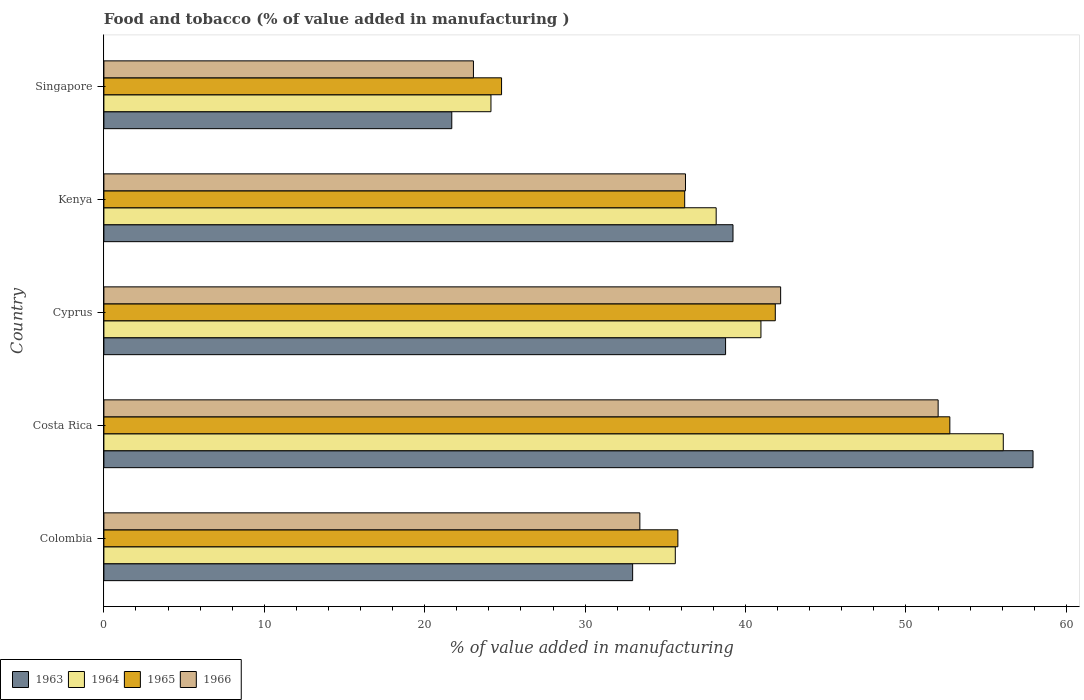How many different coloured bars are there?
Ensure brevity in your answer.  4. How many groups of bars are there?
Your answer should be compact. 5. Are the number of bars on each tick of the Y-axis equal?
Offer a very short reply. Yes. What is the label of the 4th group of bars from the top?
Keep it short and to the point. Costa Rica. In how many cases, is the number of bars for a given country not equal to the number of legend labels?
Offer a very short reply. 0. What is the value added in manufacturing food and tobacco in 1966 in Singapore?
Your answer should be very brief. 23.04. Across all countries, what is the maximum value added in manufacturing food and tobacco in 1964?
Give a very brief answer. 56.07. Across all countries, what is the minimum value added in manufacturing food and tobacco in 1964?
Ensure brevity in your answer.  24.13. In which country was the value added in manufacturing food and tobacco in 1964 minimum?
Your answer should be compact. Singapore. What is the total value added in manufacturing food and tobacco in 1964 in the graph?
Offer a terse response. 194.94. What is the difference between the value added in manufacturing food and tobacco in 1963 in Colombia and that in Costa Rica?
Your answer should be compact. -24.96. What is the difference between the value added in manufacturing food and tobacco in 1965 in Colombia and the value added in manufacturing food and tobacco in 1966 in Cyprus?
Keep it short and to the point. -6.41. What is the average value added in manufacturing food and tobacco in 1966 per country?
Make the answer very short. 37.38. What is the difference between the value added in manufacturing food and tobacco in 1965 and value added in manufacturing food and tobacco in 1963 in Kenya?
Offer a very short reply. -3.01. In how many countries, is the value added in manufacturing food and tobacco in 1964 greater than 6 %?
Your answer should be compact. 5. What is the ratio of the value added in manufacturing food and tobacco in 1966 in Kenya to that in Singapore?
Provide a succinct answer. 1.57. What is the difference between the highest and the second highest value added in manufacturing food and tobacco in 1963?
Keep it short and to the point. 18.7. What is the difference between the highest and the lowest value added in manufacturing food and tobacco in 1964?
Keep it short and to the point. 31.94. In how many countries, is the value added in manufacturing food and tobacco in 1964 greater than the average value added in manufacturing food and tobacco in 1964 taken over all countries?
Your response must be concise. 2. What does the 1st bar from the top in Cyprus represents?
Provide a short and direct response. 1966. What does the 4th bar from the bottom in Costa Rica represents?
Your answer should be very brief. 1966. Is it the case that in every country, the sum of the value added in manufacturing food and tobacco in 1966 and value added in manufacturing food and tobacco in 1963 is greater than the value added in manufacturing food and tobacco in 1964?
Ensure brevity in your answer.  Yes. How many bars are there?
Provide a succinct answer. 20. Are all the bars in the graph horizontal?
Your answer should be compact. Yes. How many countries are there in the graph?
Ensure brevity in your answer.  5. What is the difference between two consecutive major ticks on the X-axis?
Provide a short and direct response. 10. Are the values on the major ticks of X-axis written in scientific E-notation?
Your response must be concise. No. Does the graph contain any zero values?
Provide a short and direct response. No. Where does the legend appear in the graph?
Provide a succinct answer. Bottom left. How are the legend labels stacked?
Provide a short and direct response. Horizontal. What is the title of the graph?
Ensure brevity in your answer.  Food and tobacco (% of value added in manufacturing ). Does "2013" appear as one of the legend labels in the graph?
Give a very brief answer. No. What is the label or title of the X-axis?
Offer a terse response. % of value added in manufacturing. What is the % of value added in manufacturing in 1963 in Colombia?
Keep it short and to the point. 32.96. What is the % of value added in manufacturing in 1964 in Colombia?
Make the answer very short. 35.62. What is the % of value added in manufacturing in 1965 in Colombia?
Ensure brevity in your answer.  35.78. What is the % of value added in manufacturing in 1966 in Colombia?
Your answer should be very brief. 33.41. What is the % of value added in manufacturing of 1963 in Costa Rica?
Give a very brief answer. 57.92. What is the % of value added in manufacturing in 1964 in Costa Rica?
Make the answer very short. 56.07. What is the % of value added in manufacturing in 1965 in Costa Rica?
Give a very brief answer. 52.73. What is the % of value added in manufacturing in 1966 in Costa Rica?
Offer a terse response. 52. What is the % of value added in manufacturing in 1963 in Cyprus?
Your answer should be very brief. 38.75. What is the % of value added in manufacturing of 1964 in Cyprus?
Offer a very short reply. 40.96. What is the % of value added in manufacturing of 1965 in Cyprus?
Offer a terse response. 41.85. What is the % of value added in manufacturing of 1966 in Cyprus?
Ensure brevity in your answer.  42.19. What is the % of value added in manufacturing of 1963 in Kenya?
Keep it short and to the point. 39.22. What is the % of value added in manufacturing in 1964 in Kenya?
Keep it short and to the point. 38.17. What is the % of value added in manufacturing of 1965 in Kenya?
Offer a terse response. 36.2. What is the % of value added in manufacturing in 1966 in Kenya?
Your answer should be very brief. 36.25. What is the % of value added in manufacturing in 1963 in Singapore?
Make the answer very short. 21.69. What is the % of value added in manufacturing in 1964 in Singapore?
Make the answer very short. 24.13. What is the % of value added in manufacturing in 1965 in Singapore?
Provide a short and direct response. 24.79. What is the % of value added in manufacturing of 1966 in Singapore?
Offer a terse response. 23.04. Across all countries, what is the maximum % of value added in manufacturing in 1963?
Your response must be concise. 57.92. Across all countries, what is the maximum % of value added in manufacturing of 1964?
Your response must be concise. 56.07. Across all countries, what is the maximum % of value added in manufacturing of 1965?
Ensure brevity in your answer.  52.73. Across all countries, what is the maximum % of value added in manufacturing in 1966?
Offer a terse response. 52. Across all countries, what is the minimum % of value added in manufacturing of 1963?
Make the answer very short. 21.69. Across all countries, what is the minimum % of value added in manufacturing of 1964?
Give a very brief answer. 24.13. Across all countries, what is the minimum % of value added in manufacturing of 1965?
Your answer should be very brief. 24.79. Across all countries, what is the minimum % of value added in manufacturing in 1966?
Offer a very short reply. 23.04. What is the total % of value added in manufacturing in 1963 in the graph?
Offer a very short reply. 190.54. What is the total % of value added in manufacturing in 1964 in the graph?
Provide a short and direct response. 194.94. What is the total % of value added in manufacturing of 1965 in the graph?
Provide a succinct answer. 191.36. What is the total % of value added in manufacturing of 1966 in the graph?
Provide a short and direct response. 186.89. What is the difference between the % of value added in manufacturing in 1963 in Colombia and that in Costa Rica?
Make the answer very short. -24.96. What is the difference between the % of value added in manufacturing in 1964 in Colombia and that in Costa Rica?
Offer a very short reply. -20.45. What is the difference between the % of value added in manufacturing in 1965 in Colombia and that in Costa Rica?
Your answer should be compact. -16.95. What is the difference between the % of value added in manufacturing in 1966 in Colombia and that in Costa Rica?
Offer a very short reply. -18.59. What is the difference between the % of value added in manufacturing in 1963 in Colombia and that in Cyprus?
Ensure brevity in your answer.  -5.79. What is the difference between the % of value added in manufacturing in 1964 in Colombia and that in Cyprus?
Your answer should be compact. -5.34. What is the difference between the % of value added in manufacturing of 1965 in Colombia and that in Cyprus?
Give a very brief answer. -6.07. What is the difference between the % of value added in manufacturing in 1966 in Colombia and that in Cyprus?
Your answer should be very brief. -8.78. What is the difference between the % of value added in manufacturing in 1963 in Colombia and that in Kenya?
Your response must be concise. -6.26. What is the difference between the % of value added in manufacturing in 1964 in Colombia and that in Kenya?
Your answer should be very brief. -2.55. What is the difference between the % of value added in manufacturing of 1965 in Colombia and that in Kenya?
Provide a succinct answer. -0.42. What is the difference between the % of value added in manufacturing in 1966 in Colombia and that in Kenya?
Provide a short and direct response. -2.84. What is the difference between the % of value added in manufacturing in 1963 in Colombia and that in Singapore?
Ensure brevity in your answer.  11.27. What is the difference between the % of value added in manufacturing of 1964 in Colombia and that in Singapore?
Your response must be concise. 11.49. What is the difference between the % of value added in manufacturing in 1965 in Colombia and that in Singapore?
Offer a terse response. 10.99. What is the difference between the % of value added in manufacturing in 1966 in Colombia and that in Singapore?
Offer a terse response. 10.37. What is the difference between the % of value added in manufacturing in 1963 in Costa Rica and that in Cyprus?
Offer a very short reply. 19.17. What is the difference between the % of value added in manufacturing of 1964 in Costa Rica and that in Cyprus?
Your answer should be compact. 15.11. What is the difference between the % of value added in manufacturing of 1965 in Costa Rica and that in Cyprus?
Make the answer very short. 10.88. What is the difference between the % of value added in manufacturing in 1966 in Costa Rica and that in Cyprus?
Keep it short and to the point. 9.82. What is the difference between the % of value added in manufacturing of 1963 in Costa Rica and that in Kenya?
Offer a very short reply. 18.7. What is the difference between the % of value added in manufacturing of 1964 in Costa Rica and that in Kenya?
Ensure brevity in your answer.  17.9. What is the difference between the % of value added in manufacturing in 1965 in Costa Rica and that in Kenya?
Provide a succinct answer. 16.53. What is the difference between the % of value added in manufacturing in 1966 in Costa Rica and that in Kenya?
Give a very brief answer. 15.75. What is the difference between the % of value added in manufacturing of 1963 in Costa Rica and that in Singapore?
Your response must be concise. 36.23. What is the difference between the % of value added in manufacturing in 1964 in Costa Rica and that in Singapore?
Make the answer very short. 31.94. What is the difference between the % of value added in manufacturing of 1965 in Costa Rica and that in Singapore?
Keep it short and to the point. 27.94. What is the difference between the % of value added in manufacturing of 1966 in Costa Rica and that in Singapore?
Your answer should be very brief. 28.97. What is the difference between the % of value added in manufacturing in 1963 in Cyprus and that in Kenya?
Your answer should be compact. -0.46. What is the difference between the % of value added in manufacturing in 1964 in Cyprus and that in Kenya?
Make the answer very short. 2.79. What is the difference between the % of value added in manufacturing of 1965 in Cyprus and that in Kenya?
Ensure brevity in your answer.  5.65. What is the difference between the % of value added in manufacturing in 1966 in Cyprus and that in Kenya?
Keep it short and to the point. 5.93. What is the difference between the % of value added in manufacturing of 1963 in Cyprus and that in Singapore?
Give a very brief answer. 17.07. What is the difference between the % of value added in manufacturing in 1964 in Cyprus and that in Singapore?
Your response must be concise. 16.83. What is the difference between the % of value added in manufacturing of 1965 in Cyprus and that in Singapore?
Your answer should be very brief. 17.06. What is the difference between the % of value added in manufacturing of 1966 in Cyprus and that in Singapore?
Your response must be concise. 19.15. What is the difference between the % of value added in manufacturing in 1963 in Kenya and that in Singapore?
Give a very brief answer. 17.53. What is the difference between the % of value added in manufacturing of 1964 in Kenya and that in Singapore?
Give a very brief answer. 14.04. What is the difference between the % of value added in manufacturing of 1965 in Kenya and that in Singapore?
Offer a terse response. 11.41. What is the difference between the % of value added in manufacturing in 1966 in Kenya and that in Singapore?
Your answer should be compact. 13.22. What is the difference between the % of value added in manufacturing in 1963 in Colombia and the % of value added in manufacturing in 1964 in Costa Rica?
Your answer should be very brief. -23.11. What is the difference between the % of value added in manufacturing in 1963 in Colombia and the % of value added in manufacturing in 1965 in Costa Rica?
Your response must be concise. -19.77. What is the difference between the % of value added in manufacturing in 1963 in Colombia and the % of value added in manufacturing in 1966 in Costa Rica?
Ensure brevity in your answer.  -19.04. What is the difference between the % of value added in manufacturing in 1964 in Colombia and the % of value added in manufacturing in 1965 in Costa Rica?
Your answer should be compact. -17.11. What is the difference between the % of value added in manufacturing in 1964 in Colombia and the % of value added in manufacturing in 1966 in Costa Rica?
Provide a short and direct response. -16.38. What is the difference between the % of value added in manufacturing in 1965 in Colombia and the % of value added in manufacturing in 1966 in Costa Rica?
Your answer should be very brief. -16.22. What is the difference between the % of value added in manufacturing of 1963 in Colombia and the % of value added in manufacturing of 1964 in Cyprus?
Your answer should be compact. -8. What is the difference between the % of value added in manufacturing in 1963 in Colombia and the % of value added in manufacturing in 1965 in Cyprus?
Offer a very short reply. -8.89. What is the difference between the % of value added in manufacturing in 1963 in Colombia and the % of value added in manufacturing in 1966 in Cyprus?
Make the answer very short. -9.23. What is the difference between the % of value added in manufacturing of 1964 in Colombia and the % of value added in manufacturing of 1965 in Cyprus?
Ensure brevity in your answer.  -6.23. What is the difference between the % of value added in manufacturing in 1964 in Colombia and the % of value added in manufacturing in 1966 in Cyprus?
Provide a succinct answer. -6.57. What is the difference between the % of value added in manufacturing in 1965 in Colombia and the % of value added in manufacturing in 1966 in Cyprus?
Provide a succinct answer. -6.41. What is the difference between the % of value added in manufacturing of 1963 in Colombia and the % of value added in manufacturing of 1964 in Kenya?
Offer a very short reply. -5.21. What is the difference between the % of value added in manufacturing of 1963 in Colombia and the % of value added in manufacturing of 1965 in Kenya?
Give a very brief answer. -3.24. What is the difference between the % of value added in manufacturing of 1963 in Colombia and the % of value added in manufacturing of 1966 in Kenya?
Your answer should be very brief. -3.29. What is the difference between the % of value added in manufacturing of 1964 in Colombia and the % of value added in manufacturing of 1965 in Kenya?
Give a very brief answer. -0.58. What is the difference between the % of value added in manufacturing of 1964 in Colombia and the % of value added in manufacturing of 1966 in Kenya?
Offer a terse response. -0.63. What is the difference between the % of value added in manufacturing in 1965 in Colombia and the % of value added in manufacturing in 1966 in Kenya?
Provide a succinct answer. -0.47. What is the difference between the % of value added in manufacturing of 1963 in Colombia and the % of value added in manufacturing of 1964 in Singapore?
Keep it short and to the point. 8.83. What is the difference between the % of value added in manufacturing of 1963 in Colombia and the % of value added in manufacturing of 1965 in Singapore?
Give a very brief answer. 8.17. What is the difference between the % of value added in manufacturing in 1963 in Colombia and the % of value added in manufacturing in 1966 in Singapore?
Give a very brief answer. 9.92. What is the difference between the % of value added in manufacturing in 1964 in Colombia and the % of value added in manufacturing in 1965 in Singapore?
Your answer should be very brief. 10.83. What is the difference between the % of value added in manufacturing of 1964 in Colombia and the % of value added in manufacturing of 1966 in Singapore?
Make the answer very short. 12.58. What is the difference between the % of value added in manufacturing of 1965 in Colombia and the % of value added in manufacturing of 1966 in Singapore?
Provide a short and direct response. 12.74. What is the difference between the % of value added in manufacturing of 1963 in Costa Rica and the % of value added in manufacturing of 1964 in Cyprus?
Provide a short and direct response. 16.96. What is the difference between the % of value added in manufacturing of 1963 in Costa Rica and the % of value added in manufacturing of 1965 in Cyprus?
Provide a succinct answer. 16.07. What is the difference between the % of value added in manufacturing of 1963 in Costa Rica and the % of value added in manufacturing of 1966 in Cyprus?
Offer a very short reply. 15.73. What is the difference between the % of value added in manufacturing in 1964 in Costa Rica and the % of value added in manufacturing in 1965 in Cyprus?
Offer a terse response. 14.21. What is the difference between the % of value added in manufacturing in 1964 in Costa Rica and the % of value added in manufacturing in 1966 in Cyprus?
Offer a terse response. 13.88. What is the difference between the % of value added in manufacturing in 1965 in Costa Rica and the % of value added in manufacturing in 1966 in Cyprus?
Make the answer very short. 10.55. What is the difference between the % of value added in manufacturing in 1963 in Costa Rica and the % of value added in manufacturing in 1964 in Kenya?
Offer a terse response. 19.75. What is the difference between the % of value added in manufacturing in 1963 in Costa Rica and the % of value added in manufacturing in 1965 in Kenya?
Provide a short and direct response. 21.72. What is the difference between the % of value added in manufacturing in 1963 in Costa Rica and the % of value added in manufacturing in 1966 in Kenya?
Provide a succinct answer. 21.67. What is the difference between the % of value added in manufacturing of 1964 in Costa Rica and the % of value added in manufacturing of 1965 in Kenya?
Give a very brief answer. 19.86. What is the difference between the % of value added in manufacturing of 1964 in Costa Rica and the % of value added in manufacturing of 1966 in Kenya?
Give a very brief answer. 19.81. What is the difference between the % of value added in manufacturing in 1965 in Costa Rica and the % of value added in manufacturing in 1966 in Kenya?
Offer a terse response. 16.48. What is the difference between the % of value added in manufacturing in 1963 in Costa Rica and the % of value added in manufacturing in 1964 in Singapore?
Offer a very short reply. 33.79. What is the difference between the % of value added in manufacturing of 1963 in Costa Rica and the % of value added in manufacturing of 1965 in Singapore?
Your response must be concise. 33.13. What is the difference between the % of value added in manufacturing of 1963 in Costa Rica and the % of value added in manufacturing of 1966 in Singapore?
Make the answer very short. 34.88. What is the difference between the % of value added in manufacturing of 1964 in Costa Rica and the % of value added in manufacturing of 1965 in Singapore?
Keep it short and to the point. 31.28. What is the difference between the % of value added in manufacturing of 1964 in Costa Rica and the % of value added in manufacturing of 1966 in Singapore?
Your response must be concise. 33.03. What is the difference between the % of value added in manufacturing in 1965 in Costa Rica and the % of value added in manufacturing in 1966 in Singapore?
Your answer should be very brief. 29.7. What is the difference between the % of value added in manufacturing of 1963 in Cyprus and the % of value added in manufacturing of 1964 in Kenya?
Keep it short and to the point. 0.59. What is the difference between the % of value added in manufacturing in 1963 in Cyprus and the % of value added in manufacturing in 1965 in Kenya?
Your response must be concise. 2.55. What is the difference between the % of value added in manufacturing of 1963 in Cyprus and the % of value added in manufacturing of 1966 in Kenya?
Provide a short and direct response. 2.5. What is the difference between the % of value added in manufacturing of 1964 in Cyprus and the % of value added in manufacturing of 1965 in Kenya?
Ensure brevity in your answer.  4.75. What is the difference between the % of value added in manufacturing in 1964 in Cyprus and the % of value added in manufacturing in 1966 in Kenya?
Keep it short and to the point. 4.7. What is the difference between the % of value added in manufacturing of 1965 in Cyprus and the % of value added in manufacturing of 1966 in Kenya?
Your response must be concise. 5.6. What is the difference between the % of value added in manufacturing in 1963 in Cyprus and the % of value added in manufacturing in 1964 in Singapore?
Provide a short and direct response. 14.63. What is the difference between the % of value added in manufacturing of 1963 in Cyprus and the % of value added in manufacturing of 1965 in Singapore?
Your answer should be very brief. 13.96. What is the difference between the % of value added in manufacturing in 1963 in Cyprus and the % of value added in manufacturing in 1966 in Singapore?
Provide a succinct answer. 15.72. What is the difference between the % of value added in manufacturing of 1964 in Cyprus and the % of value added in manufacturing of 1965 in Singapore?
Give a very brief answer. 16.17. What is the difference between the % of value added in manufacturing in 1964 in Cyprus and the % of value added in manufacturing in 1966 in Singapore?
Keep it short and to the point. 17.92. What is the difference between the % of value added in manufacturing in 1965 in Cyprus and the % of value added in manufacturing in 1966 in Singapore?
Offer a very short reply. 18.82. What is the difference between the % of value added in manufacturing of 1963 in Kenya and the % of value added in manufacturing of 1964 in Singapore?
Provide a short and direct response. 15.09. What is the difference between the % of value added in manufacturing in 1963 in Kenya and the % of value added in manufacturing in 1965 in Singapore?
Ensure brevity in your answer.  14.43. What is the difference between the % of value added in manufacturing in 1963 in Kenya and the % of value added in manufacturing in 1966 in Singapore?
Provide a succinct answer. 16.18. What is the difference between the % of value added in manufacturing of 1964 in Kenya and the % of value added in manufacturing of 1965 in Singapore?
Provide a succinct answer. 13.38. What is the difference between the % of value added in manufacturing in 1964 in Kenya and the % of value added in manufacturing in 1966 in Singapore?
Your response must be concise. 15.13. What is the difference between the % of value added in manufacturing of 1965 in Kenya and the % of value added in manufacturing of 1966 in Singapore?
Your response must be concise. 13.17. What is the average % of value added in manufacturing of 1963 per country?
Ensure brevity in your answer.  38.11. What is the average % of value added in manufacturing of 1964 per country?
Keep it short and to the point. 38.99. What is the average % of value added in manufacturing in 1965 per country?
Provide a succinct answer. 38.27. What is the average % of value added in manufacturing in 1966 per country?
Your response must be concise. 37.38. What is the difference between the % of value added in manufacturing in 1963 and % of value added in manufacturing in 1964 in Colombia?
Make the answer very short. -2.66. What is the difference between the % of value added in manufacturing of 1963 and % of value added in manufacturing of 1965 in Colombia?
Give a very brief answer. -2.82. What is the difference between the % of value added in manufacturing of 1963 and % of value added in manufacturing of 1966 in Colombia?
Offer a very short reply. -0.45. What is the difference between the % of value added in manufacturing in 1964 and % of value added in manufacturing in 1965 in Colombia?
Your answer should be very brief. -0.16. What is the difference between the % of value added in manufacturing of 1964 and % of value added in manufacturing of 1966 in Colombia?
Ensure brevity in your answer.  2.21. What is the difference between the % of value added in manufacturing of 1965 and % of value added in manufacturing of 1966 in Colombia?
Your answer should be very brief. 2.37. What is the difference between the % of value added in manufacturing in 1963 and % of value added in manufacturing in 1964 in Costa Rica?
Your answer should be very brief. 1.85. What is the difference between the % of value added in manufacturing of 1963 and % of value added in manufacturing of 1965 in Costa Rica?
Your answer should be compact. 5.19. What is the difference between the % of value added in manufacturing of 1963 and % of value added in manufacturing of 1966 in Costa Rica?
Your answer should be very brief. 5.92. What is the difference between the % of value added in manufacturing of 1964 and % of value added in manufacturing of 1965 in Costa Rica?
Ensure brevity in your answer.  3.33. What is the difference between the % of value added in manufacturing in 1964 and % of value added in manufacturing in 1966 in Costa Rica?
Keep it short and to the point. 4.06. What is the difference between the % of value added in manufacturing of 1965 and % of value added in manufacturing of 1966 in Costa Rica?
Provide a succinct answer. 0.73. What is the difference between the % of value added in manufacturing in 1963 and % of value added in manufacturing in 1964 in Cyprus?
Provide a short and direct response. -2.2. What is the difference between the % of value added in manufacturing of 1963 and % of value added in manufacturing of 1965 in Cyprus?
Provide a short and direct response. -3.1. What is the difference between the % of value added in manufacturing in 1963 and % of value added in manufacturing in 1966 in Cyprus?
Make the answer very short. -3.43. What is the difference between the % of value added in manufacturing in 1964 and % of value added in manufacturing in 1965 in Cyprus?
Provide a succinct answer. -0.9. What is the difference between the % of value added in manufacturing of 1964 and % of value added in manufacturing of 1966 in Cyprus?
Offer a terse response. -1.23. What is the difference between the % of value added in manufacturing of 1963 and % of value added in manufacturing of 1964 in Kenya?
Provide a succinct answer. 1.05. What is the difference between the % of value added in manufacturing of 1963 and % of value added in manufacturing of 1965 in Kenya?
Ensure brevity in your answer.  3.01. What is the difference between the % of value added in manufacturing in 1963 and % of value added in manufacturing in 1966 in Kenya?
Offer a terse response. 2.96. What is the difference between the % of value added in manufacturing in 1964 and % of value added in manufacturing in 1965 in Kenya?
Offer a very short reply. 1.96. What is the difference between the % of value added in manufacturing in 1964 and % of value added in manufacturing in 1966 in Kenya?
Your answer should be very brief. 1.91. What is the difference between the % of value added in manufacturing in 1965 and % of value added in manufacturing in 1966 in Kenya?
Ensure brevity in your answer.  -0.05. What is the difference between the % of value added in manufacturing of 1963 and % of value added in manufacturing of 1964 in Singapore?
Ensure brevity in your answer.  -2.44. What is the difference between the % of value added in manufacturing of 1963 and % of value added in manufacturing of 1965 in Singapore?
Provide a short and direct response. -3.1. What is the difference between the % of value added in manufacturing in 1963 and % of value added in manufacturing in 1966 in Singapore?
Keep it short and to the point. -1.35. What is the difference between the % of value added in manufacturing of 1964 and % of value added in manufacturing of 1965 in Singapore?
Offer a very short reply. -0.66. What is the difference between the % of value added in manufacturing in 1964 and % of value added in manufacturing in 1966 in Singapore?
Your answer should be very brief. 1.09. What is the difference between the % of value added in manufacturing of 1965 and % of value added in manufacturing of 1966 in Singapore?
Ensure brevity in your answer.  1.75. What is the ratio of the % of value added in manufacturing in 1963 in Colombia to that in Costa Rica?
Provide a short and direct response. 0.57. What is the ratio of the % of value added in manufacturing in 1964 in Colombia to that in Costa Rica?
Ensure brevity in your answer.  0.64. What is the ratio of the % of value added in manufacturing in 1965 in Colombia to that in Costa Rica?
Your answer should be very brief. 0.68. What is the ratio of the % of value added in manufacturing of 1966 in Colombia to that in Costa Rica?
Offer a very short reply. 0.64. What is the ratio of the % of value added in manufacturing of 1963 in Colombia to that in Cyprus?
Ensure brevity in your answer.  0.85. What is the ratio of the % of value added in manufacturing in 1964 in Colombia to that in Cyprus?
Provide a short and direct response. 0.87. What is the ratio of the % of value added in manufacturing in 1965 in Colombia to that in Cyprus?
Your response must be concise. 0.85. What is the ratio of the % of value added in manufacturing in 1966 in Colombia to that in Cyprus?
Your answer should be compact. 0.79. What is the ratio of the % of value added in manufacturing in 1963 in Colombia to that in Kenya?
Offer a very short reply. 0.84. What is the ratio of the % of value added in manufacturing in 1964 in Colombia to that in Kenya?
Offer a very short reply. 0.93. What is the ratio of the % of value added in manufacturing of 1965 in Colombia to that in Kenya?
Offer a terse response. 0.99. What is the ratio of the % of value added in manufacturing of 1966 in Colombia to that in Kenya?
Offer a very short reply. 0.92. What is the ratio of the % of value added in manufacturing in 1963 in Colombia to that in Singapore?
Give a very brief answer. 1.52. What is the ratio of the % of value added in manufacturing of 1964 in Colombia to that in Singapore?
Keep it short and to the point. 1.48. What is the ratio of the % of value added in manufacturing of 1965 in Colombia to that in Singapore?
Provide a short and direct response. 1.44. What is the ratio of the % of value added in manufacturing of 1966 in Colombia to that in Singapore?
Offer a terse response. 1.45. What is the ratio of the % of value added in manufacturing in 1963 in Costa Rica to that in Cyprus?
Give a very brief answer. 1.49. What is the ratio of the % of value added in manufacturing in 1964 in Costa Rica to that in Cyprus?
Your response must be concise. 1.37. What is the ratio of the % of value added in manufacturing of 1965 in Costa Rica to that in Cyprus?
Offer a very short reply. 1.26. What is the ratio of the % of value added in manufacturing in 1966 in Costa Rica to that in Cyprus?
Offer a terse response. 1.23. What is the ratio of the % of value added in manufacturing in 1963 in Costa Rica to that in Kenya?
Keep it short and to the point. 1.48. What is the ratio of the % of value added in manufacturing in 1964 in Costa Rica to that in Kenya?
Provide a succinct answer. 1.47. What is the ratio of the % of value added in manufacturing of 1965 in Costa Rica to that in Kenya?
Provide a short and direct response. 1.46. What is the ratio of the % of value added in manufacturing in 1966 in Costa Rica to that in Kenya?
Your answer should be very brief. 1.43. What is the ratio of the % of value added in manufacturing of 1963 in Costa Rica to that in Singapore?
Provide a short and direct response. 2.67. What is the ratio of the % of value added in manufacturing of 1964 in Costa Rica to that in Singapore?
Make the answer very short. 2.32. What is the ratio of the % of value added in manufacturing of 1965 in Costa Rica to that in Singapore?
Your answer should be very brief. 2.13. What is the ratio of the % of value added in manufacturing in 1966 in Costa Rica to that in Singapore?
Provide a succinct answer. 2.26. What is the ratio of the % of value added in manufacturing of 1964 in Cyprus to that in Kenya?
Provide a short and direct response. 1.07. What is the ratio of the % of value added in manufacturing of 1965 in Cyprus to that in Kenya?
Offer a terse response. 1.16. What is the ratio of the % of value added in manufacturing in 1966 in Cyprus to that in Kenya?
Keep it short and to the point. 1.16. What is the ratio of the % of value added in manufacturing in 1963 in Cyprus to that in Singapore?
Make the answer very short. 1.79. What is the ratio of the % of value added in manufacturing of 1964 in Cyprus to that in Singapore?
Offer a terse response. 1.7. What is the ratio of the % of value added in manufacturing of 1965 in Cyprus to that in Singapore?
Provide a succinct answer. 1.69. What is the ratio of the % of value added in manufacturing in 1966 in Cyprus to that in Singapore?
Provide a succinct answer. 1.83. What is the ratio of the % of value added in manufacturing in 1963 in Kenya to that in Singapore?
Offer a terse response. 1.81. What is the ratio of the % of value added in manufacturing of 1964 in Kenya to that in Singapore?
Provide a short and direct response. 1.58. What is the ratio of the % of value added in manufacturing of 1965 in Kenya to that in Singapore?
Give a very brief answer. 1.46. What is the ratio of the % of value added in manufacturing of 1966 in Kenya to that in Singapore?
Ensure brevity in your answer.  1.57. What is the difference between the highest and the second highest % of value added in manufacturing in 1963?
Provide a succinct answer. 18.7. What is the difference between the highest and the second highest % of value added in manufacturing in 1964?
Make the answer very short. 15.11. What is the difference between the highest and the second highest % of value added in manufacturing of 1965?
Your answer should be very brief. 10.88. What is the difference between the highest and the second highest % of value added in manufacturing of 1966?
Provide a short and direct response. 9.82. What is the difference between the highest and the lowest % of value added in manufacturing of 1963?
Make the answer very short. 36.23. What is the difference between the highest and the lowest % of value added in manufacturing of 1964?
Give a very brief answer. 31.94. What is the difference between the highest and the lowest % of value added in manufacturing of 1965?
Provide a short and direct response. 27.94. What is the difference between the highest and the lowest % of value added in manufacturing of 1966?
Ensure brevity in your answer.  28.97. 